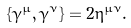<formula> <loc_0><loc_0><loc_500><loc_500>\{ \gamma ^ { \mu } , \gamma ^ { \nu } \} = 2 \eta ^ { \mu \nu } .</formula> 